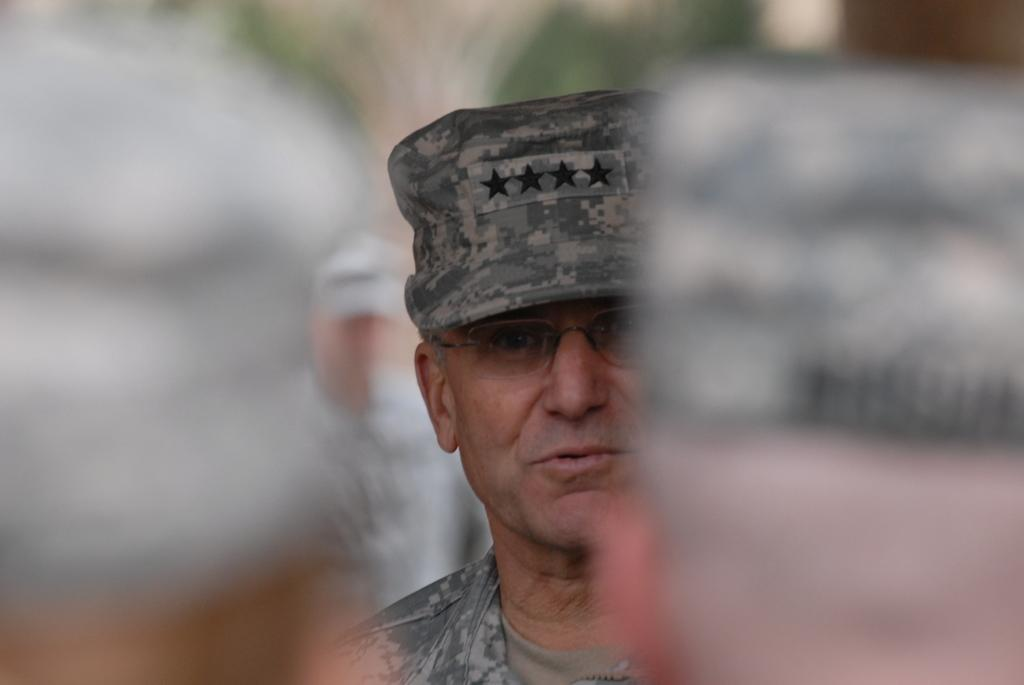How many people are in the image? There are four persons in the image. What is the appearance of the man in the middle? The man in the middle is wearing a cap and spectacles. Can you describe the background of the image? The background of the image is blurry. What type of metal can be seen in the man's bun in the image? There is no man with a bun in the image, and therefore no metal can be seen in it. 